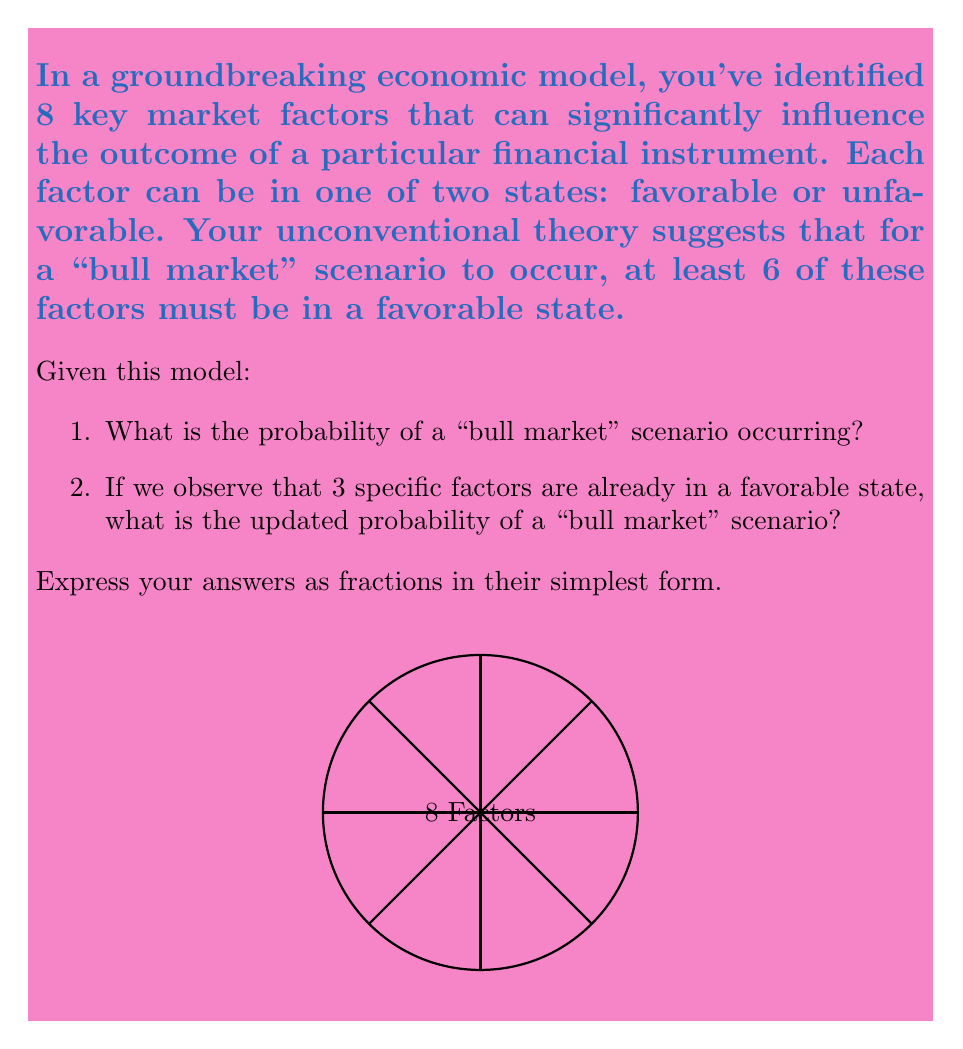Could you help me with this problem? Let's approach this step-by-step using combinatorial analysis:

1) For the first part of the question:

   - We need to calculate the probability of having 6, 7, or 8 factors in a favorable state out of 8 total factors.
   - This can be represented as: $P(\text{bull market}) = \frac{\binom{8}{6} + \binom{8}{7} + \binom{8}{8}}{2^8}$
   
   Let's calculate each part:
   $$\binom{8}{6} = 28$$
   $$\binom{8}{7} = 8$$
   $$\binom{8}{8} = 1$$
   
   Total favorable outcomes: $28 + 8 + 1 = 37$
   Total possible outcomes: $2^8 = 256$

   Therefore, $P(\text{bull market}) = \frac{37}{256}$

2) For the second part:

   - We now know that 3 factors are already favorable, so we need 3, 4, or 5 more favorable factors out of the remaining 5.
   - This can be represented as: $P(\text{bull market | 3 favorable}) = \frac{\binom{5}{3} + \binom{5}{4} + \binom{5}{5}}{2^5}$

   Let's calculate:
   $$\binom{5}{3} = 10$$
   $$\binom{5}{4} = 5$$
   $$\binom{5}{5} = 1$$

   Total favorable outcomes: $10 + 5 + 1 = 16$
   Total possible outcomes: $2^5 = 32$

   Therefore, $P(\text{bull market | 3 favorable}) = \frac{16}{32} = \frac{1}{2}$

Both fractions are already in their simplest form.
Answer: 1) $\frac{37}{256}$
2) $\frac{1}{2}$ 